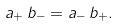Convert formula to latex. <formula><loc_0><loc_0><loc_500><loc_500>a _ { + } \, b _ { - } = a _ { - } \, b _ { + } .</formula> 